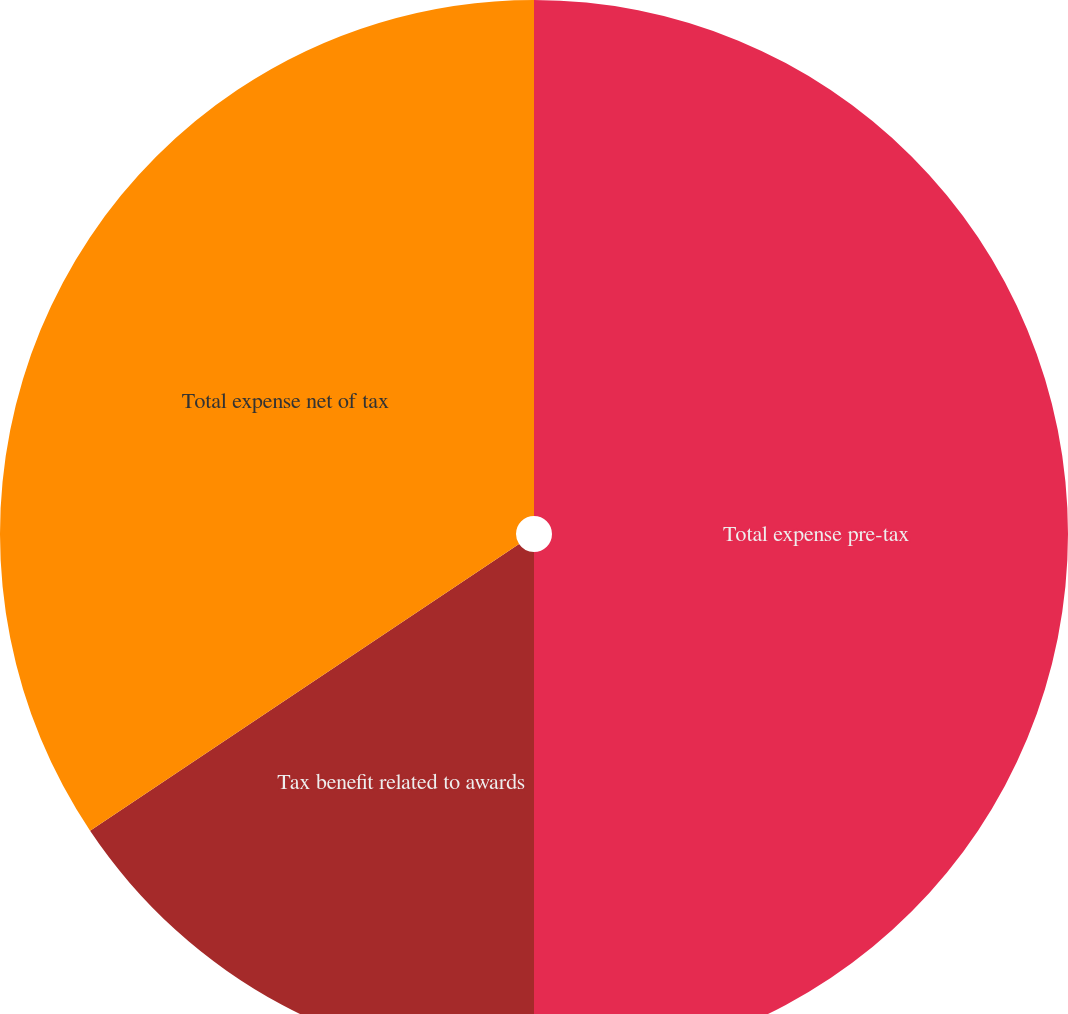Convert chart to OTSL. <chart><loc_0><loc_0><loc_500><loc_500><pie_chart><fcel>Total expense pre-tax<fcel>Tax benefit related to awards<fcel>Total expense net of tax<nl><fcel>50.0%<fcel>15.62%<fcel>34.38%<nl></chart> 